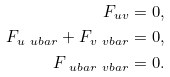Convert formula to latex. <formula><loc_0><loc_0><loc_500><loc_500>F _ { u v } = 0 , \\ F _ { u { \ u b a r } } + F _ { v { \ v b a r } } = 0 , \\ F _ { { \ u b a r } { \ v b a r } } = 0 .</formula> 